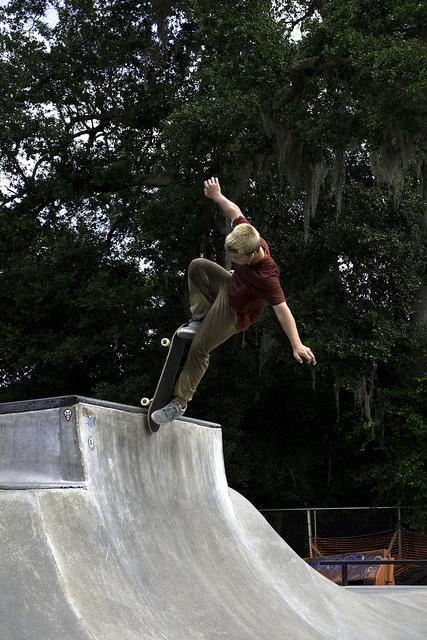How many couches are in the photo?
Give a very brief answer. 0. 